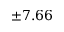Convert formula to latex. <formula><loc_0><loc_0><loc_500><loc_500>\pm 7 . 6 6</formula> 